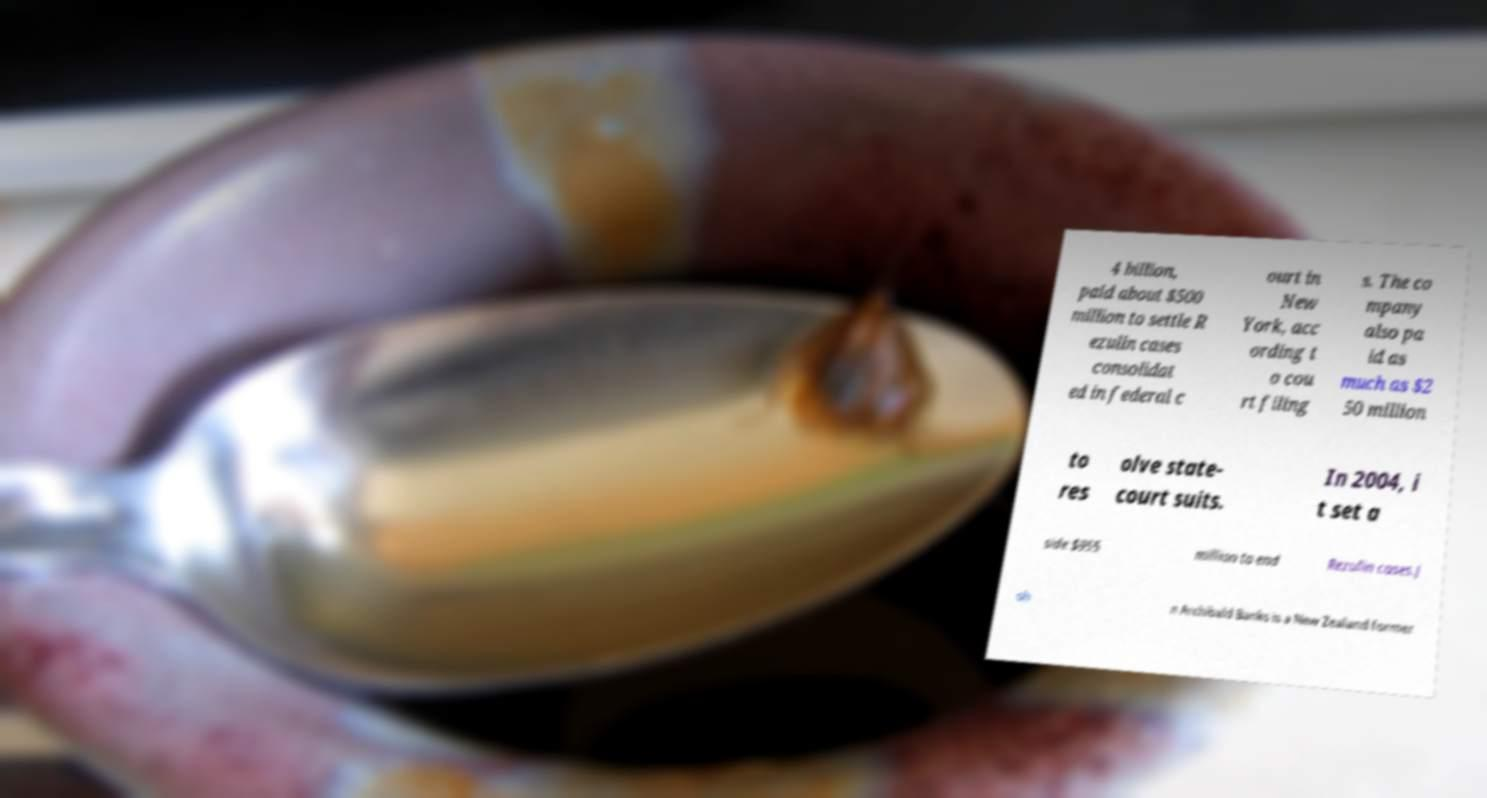Could you extract and type out the text from this image? 4 billion, paid about $500 million to settle R ezulin cases consolidat ed in federal c ourt in New York, acc ording t o cou rt filing s. The co mpany also pa id as much as $2 50 million to res olve state- court suits. In 2004, i t set a side $955 million to end Rezulin cases.J oh n Archibald Banks is a New Zealand former 